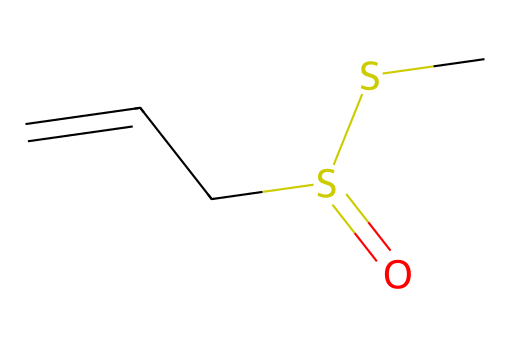How many sulfur atoms are present in the structure? The structure shows two distinct sulfur atoms connected by a single bond, confirmed by the presence of "S" in the SMILES notation.
Answer: two What functional groups are present in allicin? The structure includes a sulfoxide group (S=O) and a thioether linkage (C-S-C), derived from the presence of the sulfur atoms in different bonding scenarios.
Answer: sulfoxide and thioether What is the total number of carbon atoms in this compound? By counting the "C" in the SMILES notation, there are four carbon atoms present in the overall structure of allicin.
Answer: four Is allicin classified as an organosulfur compound? Allicin contains sulfur atoms covalently bonded to carbon atoms, which fits the criteria for organosulfur compounds.
Answer: yes What type of bonding is present between the sulfur and carbon atoms in allicin? The bonding established in the SMILES indicates single and double covalent bonds between the sulfur and carbon atoms, reflecting characteristic bonding in organosulfur chemistry.
Answer: covalent What is the significance of the double bond in the structure of allicin? The double bond between the carbon and sulfur (C=S) is indicative of the compound's reactivity and contributes to its biological properties, relevant to its effects as an organosulfur compound.
Answer: reactivity Can allicin contribute to health benefits in athletes? Allicin is known for its potential health benefits, such as anti-inflammatory and antioxidant properties, which may enhance athletic performance and recovery.
Answer: yes 